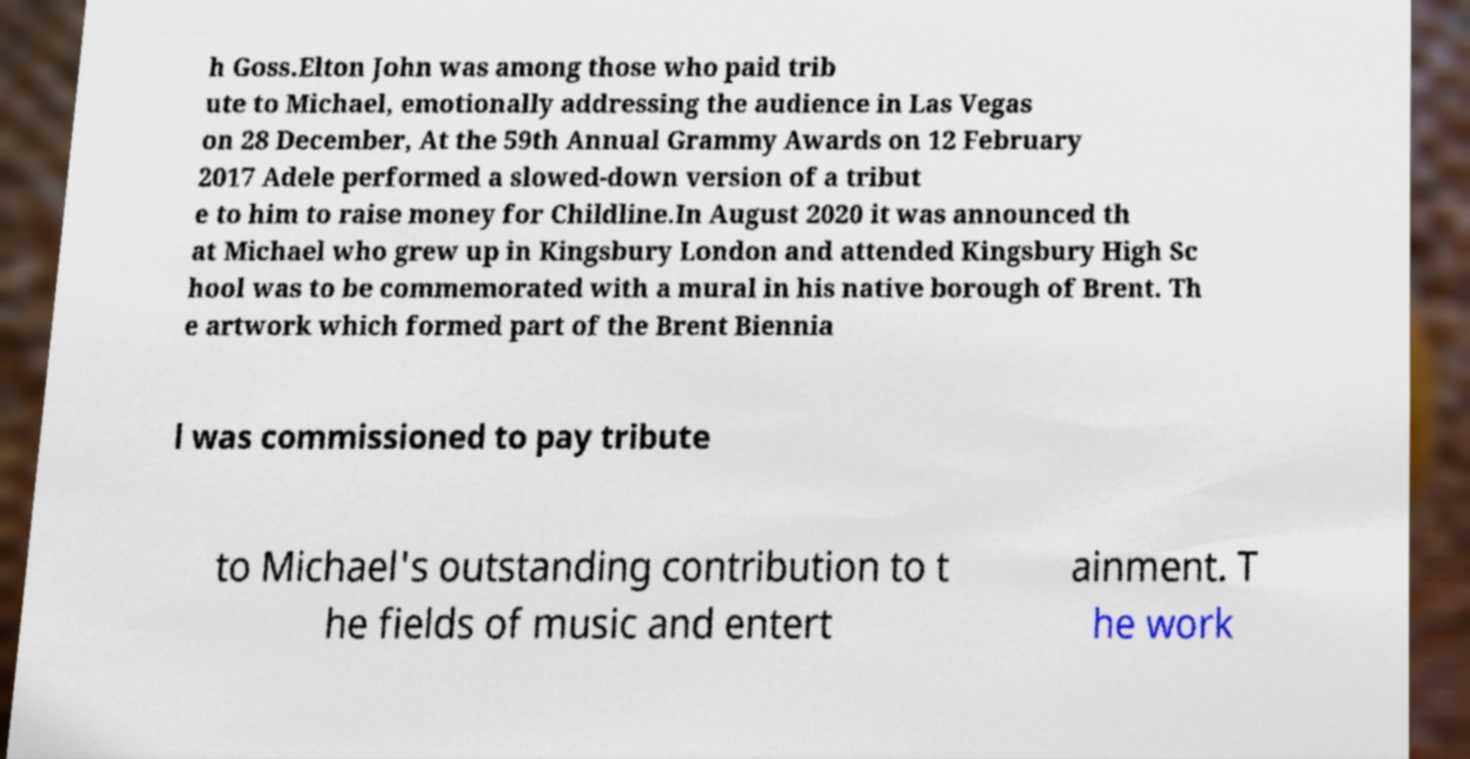What messages or text are displayed in this image? I need them in a readable, typed format. h Goss.Elton John was among those who paid trib ute to Michael, emotionally addressing the audience in Las Vegas on 28 December, At the 59th Annual Grammy Awards on 12 February 2017 Adele performed a slowed-down version of a tribut e to him to raise money for Childline.In August 2020 it was announced th at Michael who grew up in Kingsbury London and attended Kingsbury High Sc hool was to be commemorated with a mural in his native borough of Brent. Th e artwork which formed part of the Brent Biennia l was commissioned to pay tribute to Michael's outstanding contribution to t he fields of music and entert ainment. T he work 